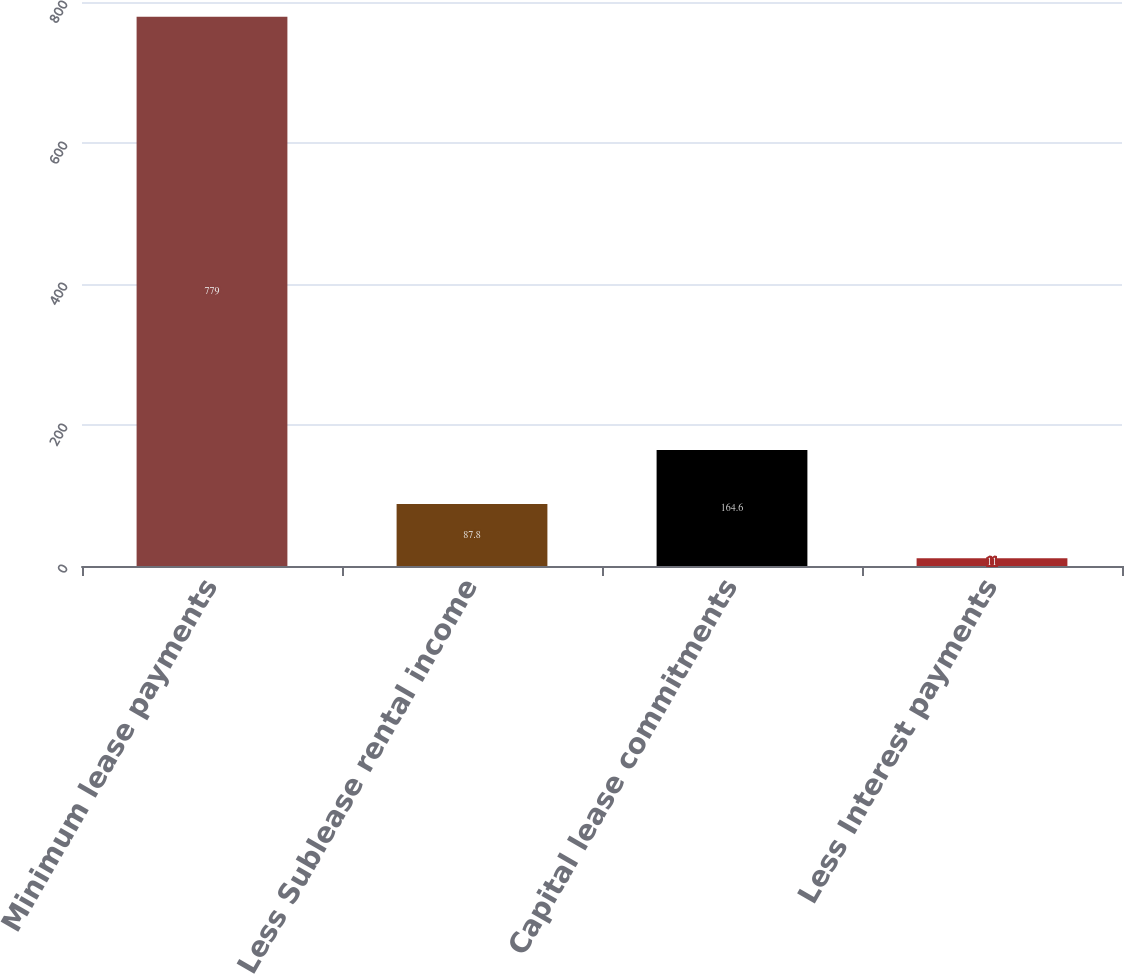<chart> <loc_0><loc_0><loc_500><loc_500><bar_chart><fcel>Minimum lease payments<fcel>Less Sublease rental income<fcel>Capital lease commitments<fcel>Less Interest payments<nl><fcel>779<fcel>87.8<fcel>164.6<fcel>11<nl></chart> 